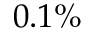<formula> <loc_0><loc_0><loc_500><loc_500>0 . 1 \%</formula> 